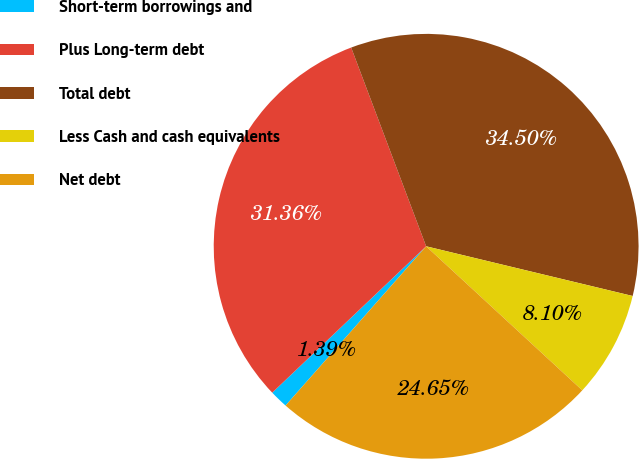Convert chart to OTSL. <chart><loc_0><loc_0><loc_500><loc_500><pie_chart><fcel>Short-term borrowings and<fcel>Plus Long-term debt<fcel>Total debt<fcel>Less Cash and cash equivalents<fcel>Net debt<nl><fcel>1.39%<fcel>31.36%<fcel>34.5%<fcel>8.1%<fcel>24.65%<nl></chart> 